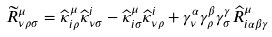<formula> <loc_0><loc_0><loc_500><loc_500>\widetilde { R } _ { \nu \rho \sigma } ^ { \mu } = \widehat { \kappa } _ { i \rho } ^ { \mu } \widehat { \kappa } _ { \nu \sigma } ^ { i } - \widehat { \kappa } _ { i \sigma } ^ { \mu } \widehat { \kappa } _ { \nu \rho } ^ { i } + \gamma _ { \nu } ^ { \alpha } \gamma _ { \rho } ^ { \beta } \gamma _ { \sigma } ^ { \gamma } \widehat { R } _ { i \alpha \beta \gamma } ^ { \mu }</formula> 